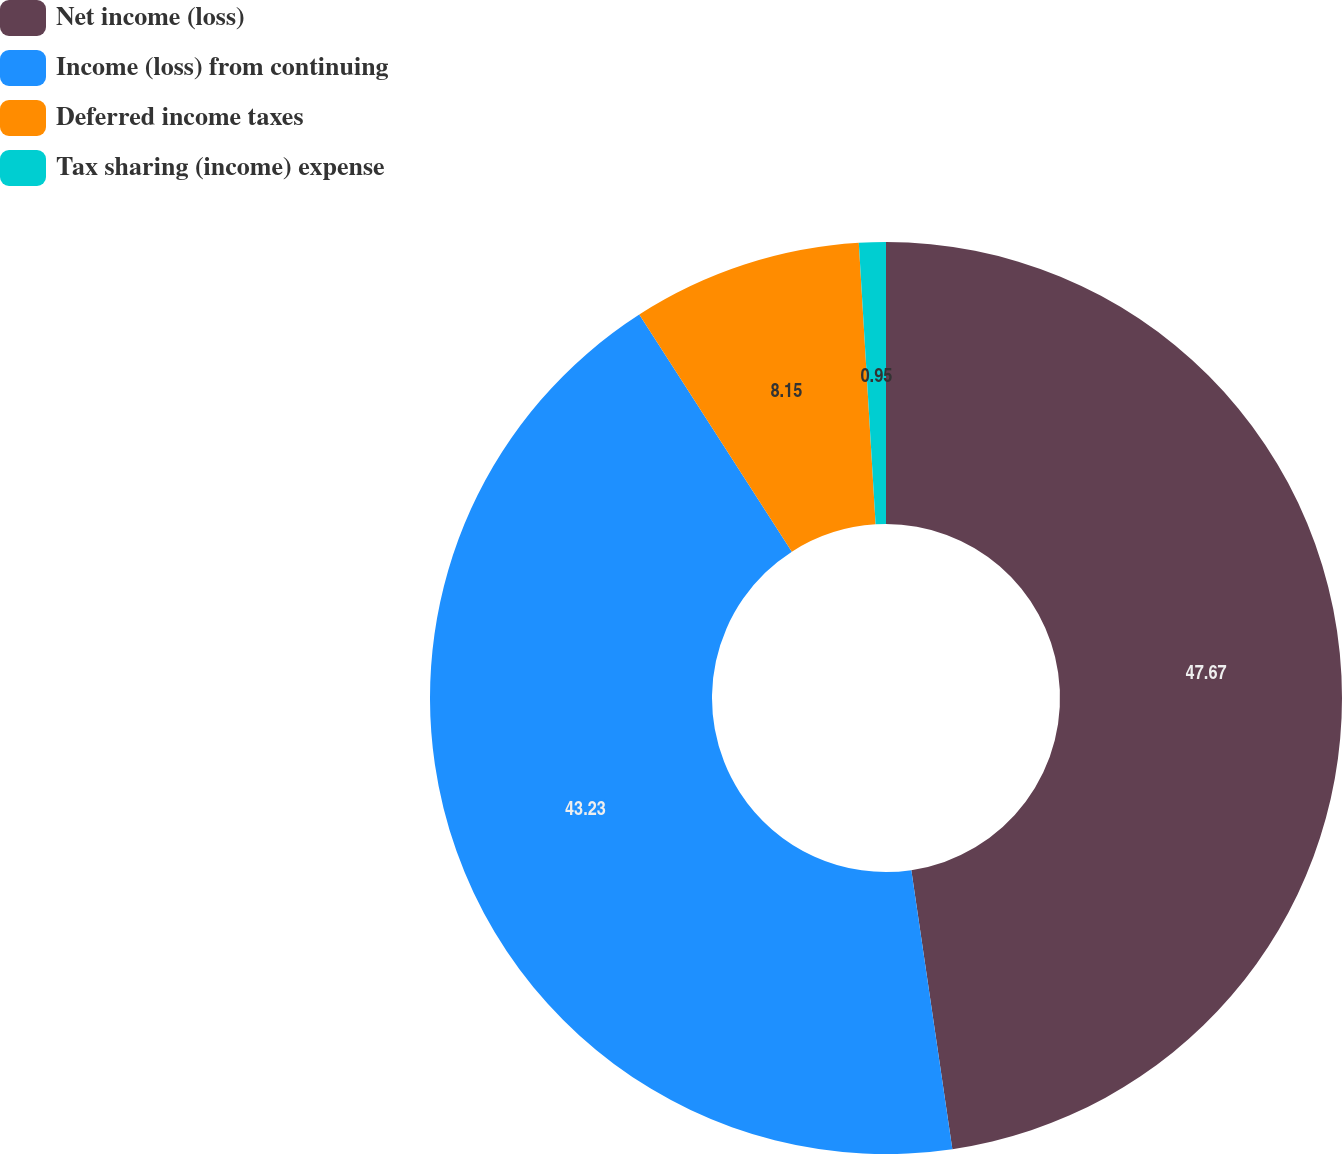Convert chart to OTSL. <chart><loc_0><loc_0><loc_500><loc_500><pie_chart><fcel>Net income (loss)<fcel>Income (loss) from continuing<fcel>Deferred income taxes<fcel>Tax sharing (income) expense<nl><fcel>47.68%<fcel>43.23%<fcel>8.15%<fcel>0.95%<nl></chart> 